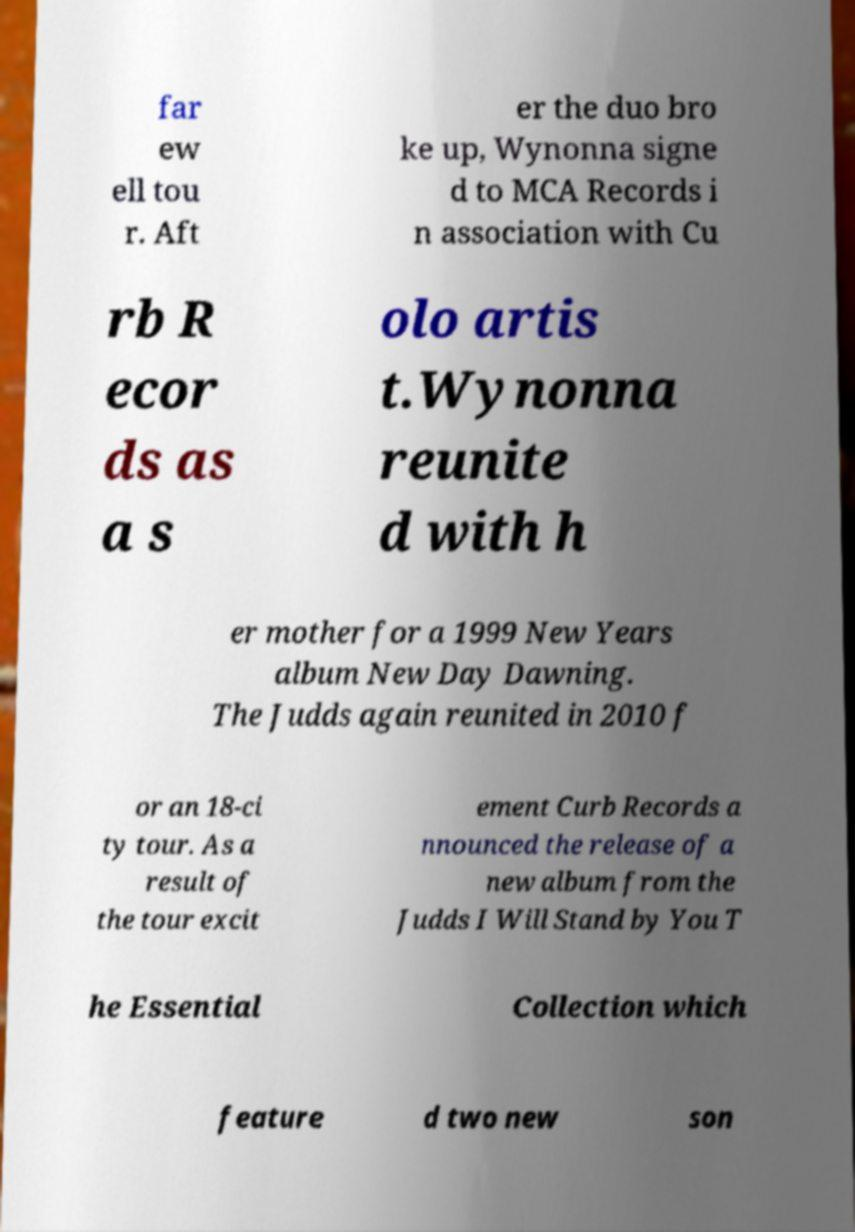Please read and relay the text visible in this image. What does it say? far ew ell tou r. Aft er the duo bro ke up, Wynonna signe d to MCA Records i n association with Cu rb R ecor ds as a s olo artis t.Wynonna reunite d with h er mother for a 1999 New Years album New Day Dawning. The Judds again reunited in 2010 f or an 18-ci ty tour. As a result of the tour excit ement Curb Records a nnounced the release of a new album from the Judds I Will Stand by You T he Essential Collection which feature d two new son 